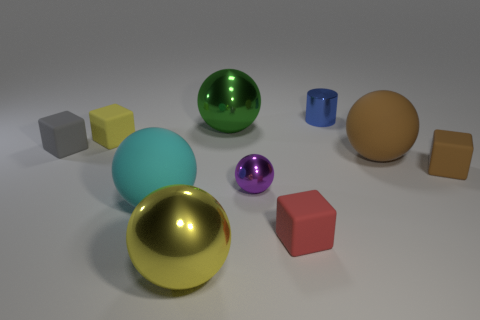Subtract 1 cubes. How many cubes are left? 3 Subtract all green spheres. How many spheres are left? 4 Subtract all small metal spheres. How many spheres are left? 4 Subtract all red spheres. Subtract all red cylinders. How many spheres are left? 5 Subtract all cylinders. How many objects are left? 9 Add 7 small blue cylinders. How many small blue cylinders are left? 8 Add 5 big cyan matte cylinders. How many big cyan matte cylinders exist? 5 Subtract 1 cyan balls. How many objects are left? 9 Subtract all purple shiny things. Subtract all big green metallic balls. How many objects are left? 8 